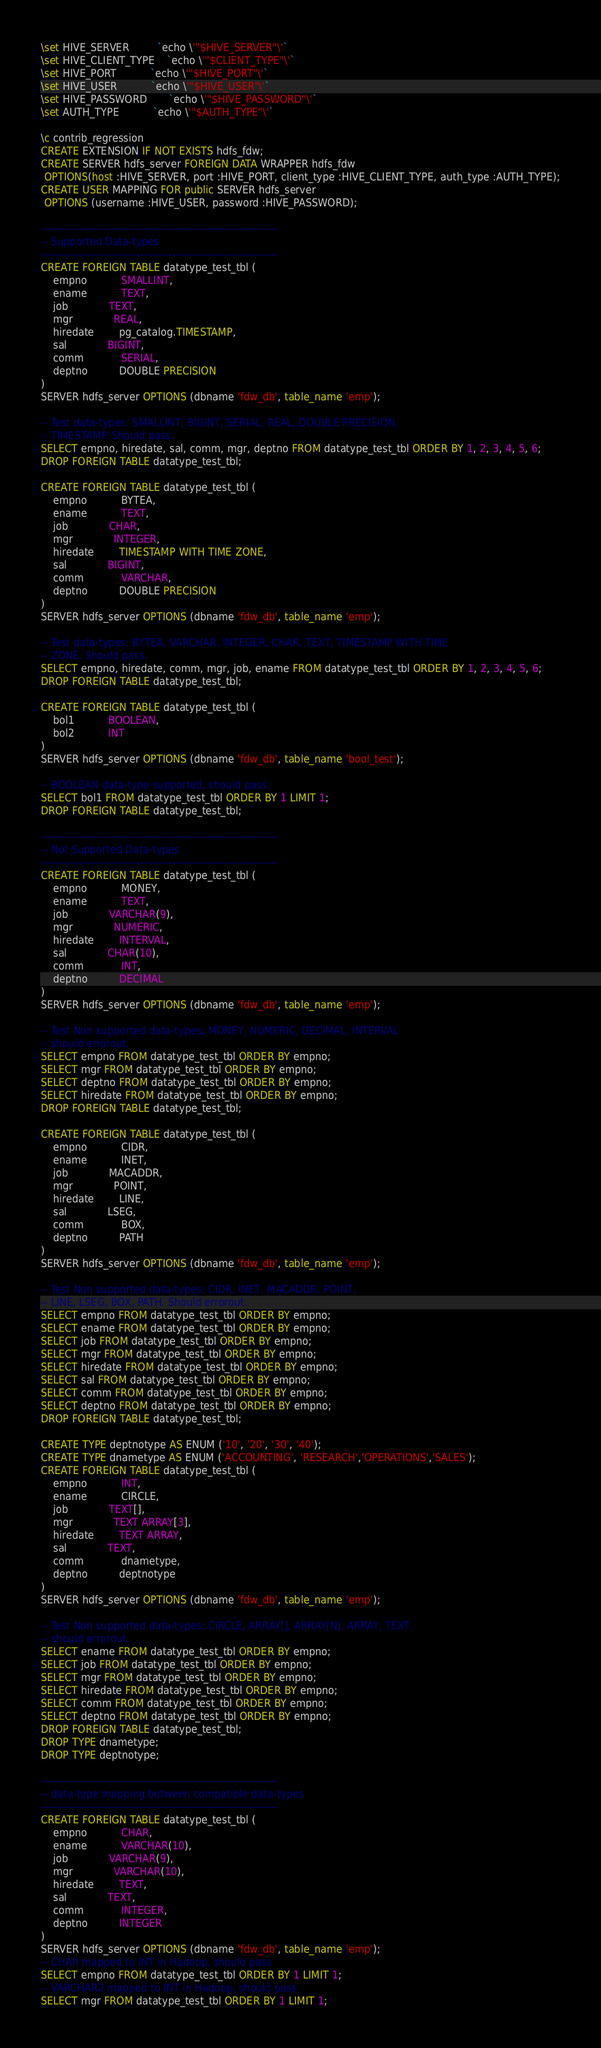<code> <loc_0><loc_0><loc_500><loc_500><_SQL_>\set HIVE_SERVER         `echo \'"$HIVE_SERVER"\'`
\set HIVE_CLIENT_TYPE    `echo \'"$CLIENT_TYPE"\'`
\set HIVE_PORT           `echo \'"$HIVE_PORT"\'`
\set HIVE_USER           `echo \'"$HIVE_USER"\'`
\set HIVE_PASSWORD       `echo \'"$HIVE_PASSWORD"\'`
\set AUTH_TYPE           `echo \'"$AUTH_TYPE"\'`

\c contrib_regression
CREATE EXTENSION IF NOT EXISTS hdfs_fdw;
CREATE SERVER hdfs_server FOREIGN DATA WRAPPER hdfs_fdw
 OPTIONS(host :HIVE_SERVER, port :HIVE_PORT, client_type :HIVE_CLIENT_TYPE, auth_type :AUTH_TYPE);
CREATE USER MAPPING FOR public SERVER hdfs_server
 OPTIONS (username :HIVE_USER, password :HIVE_PASSWORD);

-------------------------------------------------------------------
-- Supported Data-types
-------------------------------------------------------------------
CREATE FOREIGN TABLE datatype_test_tbl (
    empno           SMALLINT,
    ename           TEXT,
    job             TEXT,
    mgr             REAL,
    hiredate        pg_catalog.TIMESTAMP,
    sal             BIGINT,
    comm            SERIAL,
    deptno          DOUBLE PRECISION
)
SERVER hdfs_server OPTIONS (dbname 'fdw_db', table_name 'emp');

-- Test data-types: SMALLINT, BIGINT, SERIAL, REAL, DOUBLE PRECISION,
-- TIMESTAMP. Should pass.
SELECT empno, hiredate, sal, comm, mgr, deptno FROM datatype_test_tbl ORDER BY 1, 2, 3, 4, 5, 6;
DROP FOREIGN TABLE datatype_test_tbl;

CREATE FOREIGN TABLE datatype_test_tbl (
    empno           BYTEA,
    ename           TEXT,
    job             CHAR,
    mgr             INTEGER,
    hiredate        TIMESTAMP WITH TIME ZONE,
    sal             BIGINT,
    comm            VARCHAR,
    deptno          DOUBLE PRECISION
)
SERVER hdfs_server OPTIONS (dbname 'fdw_db', table_name 'emp');

-- Test data-types: BYTEA, VARCHAR, INTEGER, CHAR, TEXT, TIMESTAMP WITH TIME
-- ZONE. Should pass.
SELECT empno, hiredate, comm, mgr, job, ename FROM datatype_test_tbl ORDER BY 1, 2, 3, 4, 5, 6;
DROP FOREIGN TABLE datatype_test_tbl;

CREATE FOREIGN TABLE datatype_test_tbl (
    bol1           BOOLEAN,
    bol2           INT
)
SERVER hdfs_server OPTIONS (dbname 'fdw_db', table_name 'bool_test');

-- BOOLEAN data-type supported, should pass.
SELECT bol1 FROM datatype_test_tbl ORDER BY 1 LIMIT 1;
DROP FOREIGN TABLE datatype_test_tbl;

-------------------------------------------------------------------
-- Not Supported Data-types
-------------------------------------------------------------------
CREATE FOREIGN TABLE datatype_test_tbl (
    empno           MONEY,
    ename           TEXT,
    job             VARCHAR(9),
    mgr             NUMERIC,
    hiredate        INTERVAL,
    sal             CHAR(10),
    comm            INT,
    deptno          DECIMAL
)
SERVER hdfs_server OPTIONS (dbname 'fdw_db', table_name 'emp');

-- Test Non supported data-types: MONEY, NUMERIC, DECIMAL, INTERVAL
-- should errorout.
SELECT empno FROM datatype_test_tbl ORDER BY empno;
SELECT mgr FROM datatype_test_tbl ORDER BY empno;
SELECT deptno FROM datatype_test_tbl ORDER BY empno;
SELECT hiredate FROM datatype_test_tbl ORDER BY empno;
DROP FOREIGN TABLE datatype_test_tbl;

CREATE FOREIGN TABLE datatype_test_tbl (
    empno           CIDR,
    ename           INET,
    job             MACADDR,
    mgr             POINT,
    hiredate        LINE,
    sal             LSEG,
    comm            BOX,
    deptno          PATH
)
SERVER hdfs_server OPTIONS (dbname 'fdw_db', table_name 'emp');

-- Test Non supported data-types: CIDR, INET, MACADDR, POINT,
-- LINE, LSEG, BOX, PATH. Should errorout.
SELECT empno FROM datatype_test_tbl ORDER BY empno;
SELECT ename FROM datatype_test_tbl ORDER BY empno;
SELECT job FROM datatype_test_tbl ORDER BY empno;
SELECT mgr FROM datatype_test_tbl ORDER BY empno;
SELECT hiredate FROM datatype_test_tbl ORDER BY empno;
SELECT sal FROM datatype_test_tbl ORDER BY empno;
SELECT comm FROM datatype_test_tbl ORDER BY empno;
SELECT deptno FROM datatype_test_tbl ORDER BY empno;
DROP FOREIGN TABLE datatype_test_tbl;

CREATE TYPE deptnotype AS ENUM ('10', '20', '30', '40');
CREATE TYPE dnametype AS ENUM ('ACCOUNTING', 'RESEARCH','OPERATIONS','SALES');
CREATE FOREIGN TABLE datatype_test_tbl (
    empno           INT,
    ename           CIRCLE,
    job             TEXT[],
    mgr             TEXT ARRAY[3],
    hiredate        TEXT ARRAY,
    sal             TEXT,
    comm            dnametype,
    deptno          deptnotype
)
SERVER hdfs_server OPTIONS (dbname 'fdw_db', table_name 'emp');

-- Test Non supported data-types: CIRCLE, ARRAY[], ARRAY[N], ARRAY, TEXT
-- should errorout.
SELECT ename FROM datatype_test_tbl ORDER BY empno;
SELECT job FROM datatype_test_tbl ORDER BY empno;
SELECT mgr FROM datatype_test_tbl ORDER BY empno;
SELECT hiredate FROM datatype_test_tbl ORDER BY empno;
SELECT comm FROM datatype_test_tbl ORDER BY empno;
SELECT deptno FROM datatype_test_tbl ORDER BY empno;
DROP FOREIGN TABLE datatype_test_tbl;
DROP TYPE dnametype;
DROP TYPE deptnotype;

-------------------------------------------------------------------
-- data-type mapping between compatible data-types
-------------------------------------------------------------------
CREATE FOREIGN TABLE datatype_test_tbl (
    empno           CHAR,
    ename           VARCHAR(10),
    job             VARCHAR(9),
    mgr             VARCHAR(10),
    hiredate        TEXT,
    sal             TEXT,
    comm            INTEGER,
    deptno          INTEGER
)
SERVER hdfs_server OPTIONS (dbname 'fdw_db', table_name 'emp');
-- CHAR mapped to INT in Hadoop, should pass
SELECT empno FROM datatype_test_tbl ORDER BY 1 LIMIT 1;
-- VARCHAR2 mapped to INT in Hadoop, should pass
SELECT mgr FROM datatype_test_tbl ORDER BY 1 LIMIT 1;</code> 